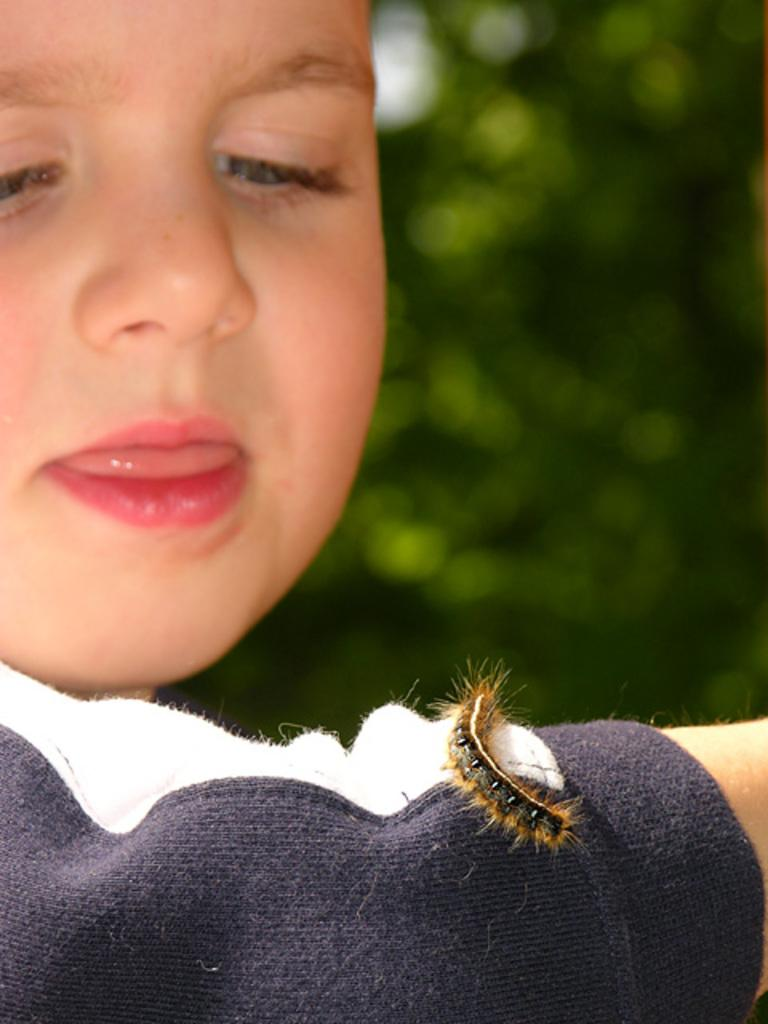Who is the main subject in the image? There is a boy in the image. What is on the boy's hand? There is a caterpillar on the boy's hand. Can you describe the background of the image? The background of the image is blurred. How long does it take for the boy's nose to grow in the image? There is no information about the boy's nose in the image, so it is impossible to determine how long it takes for it to grow. 